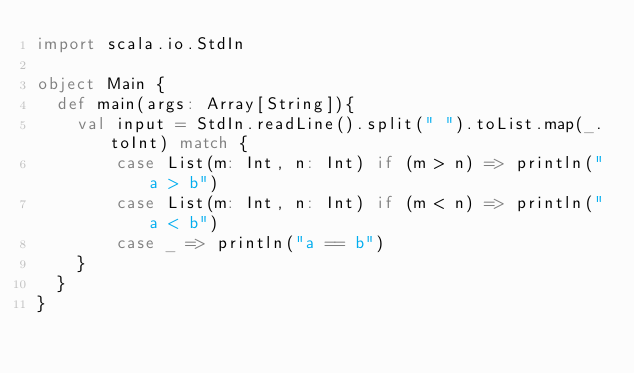Convert code to text. <code><loc_0><loc_0><loc_500><loc_500><_Scala_>import scala.io.StdIn

object Main {
  def main(args: Array[String]){
    val input = StdIn.readLine().split(" ").toList.map(_.toInt) match {
        case List(m: Int, n: Int) if (m > n) => println("a > b")
        case List(m: Int, n: Int) if (m < n) => println("a < b")
        case _ => println("a == b")
    }
  }
}

</code> 